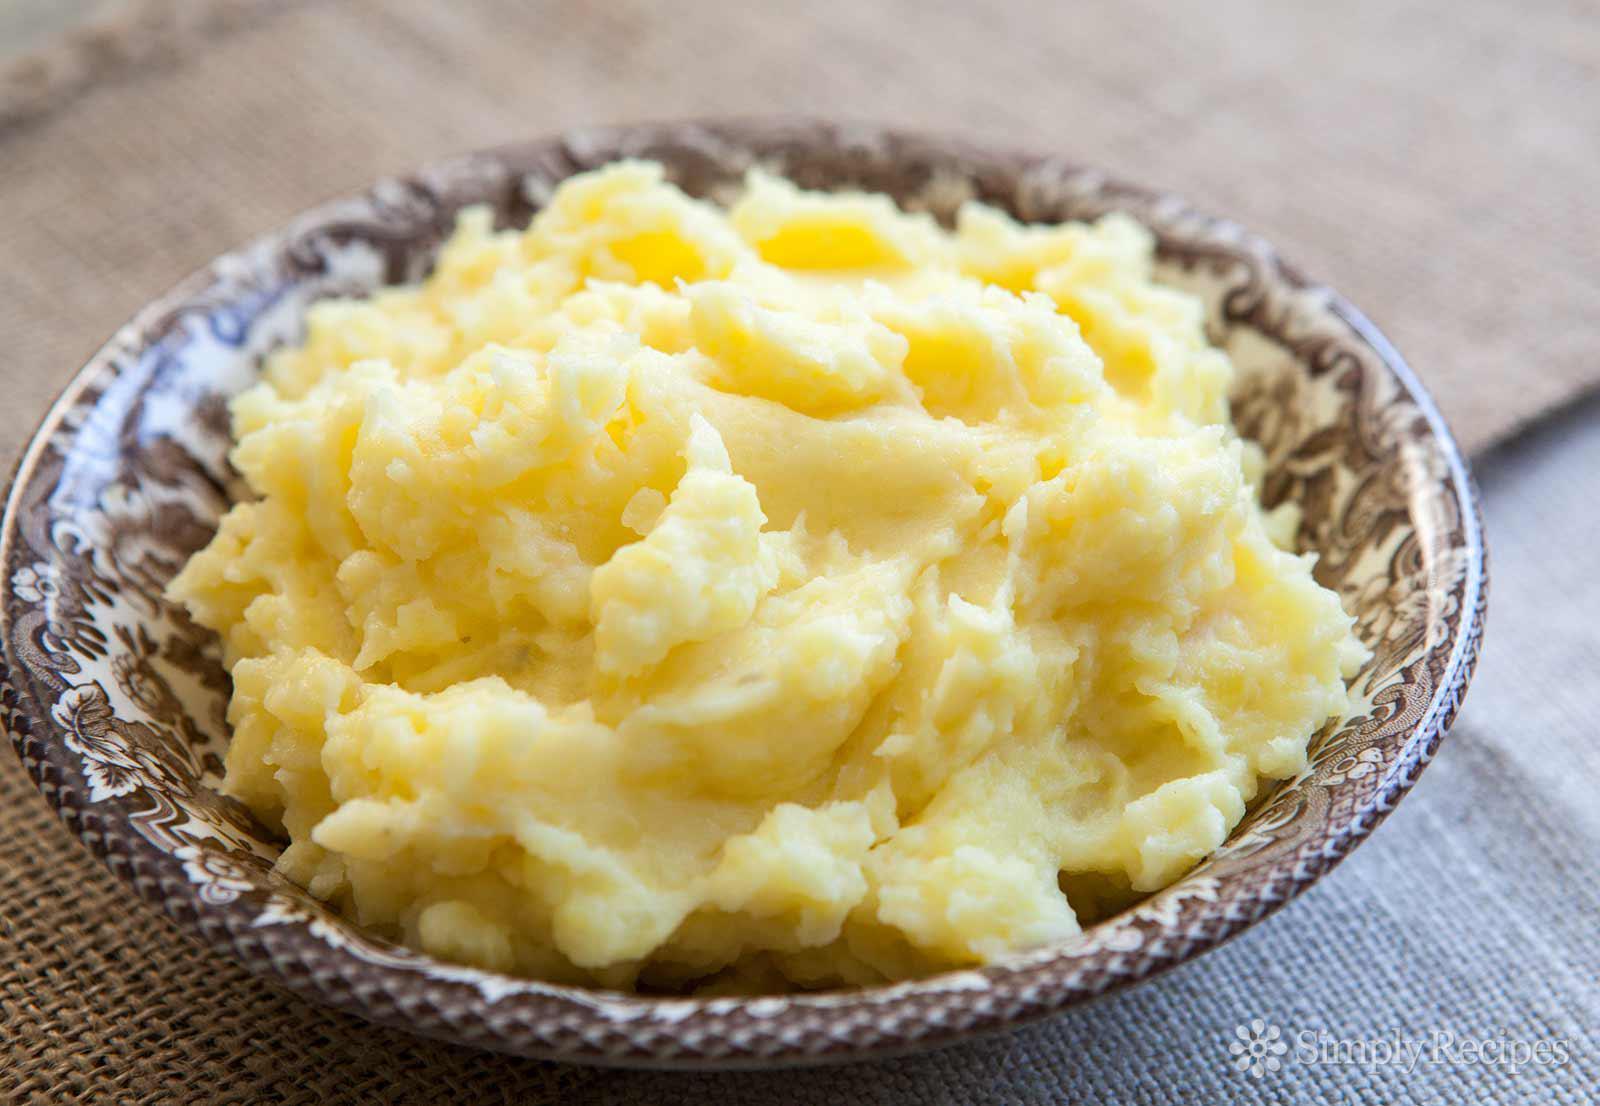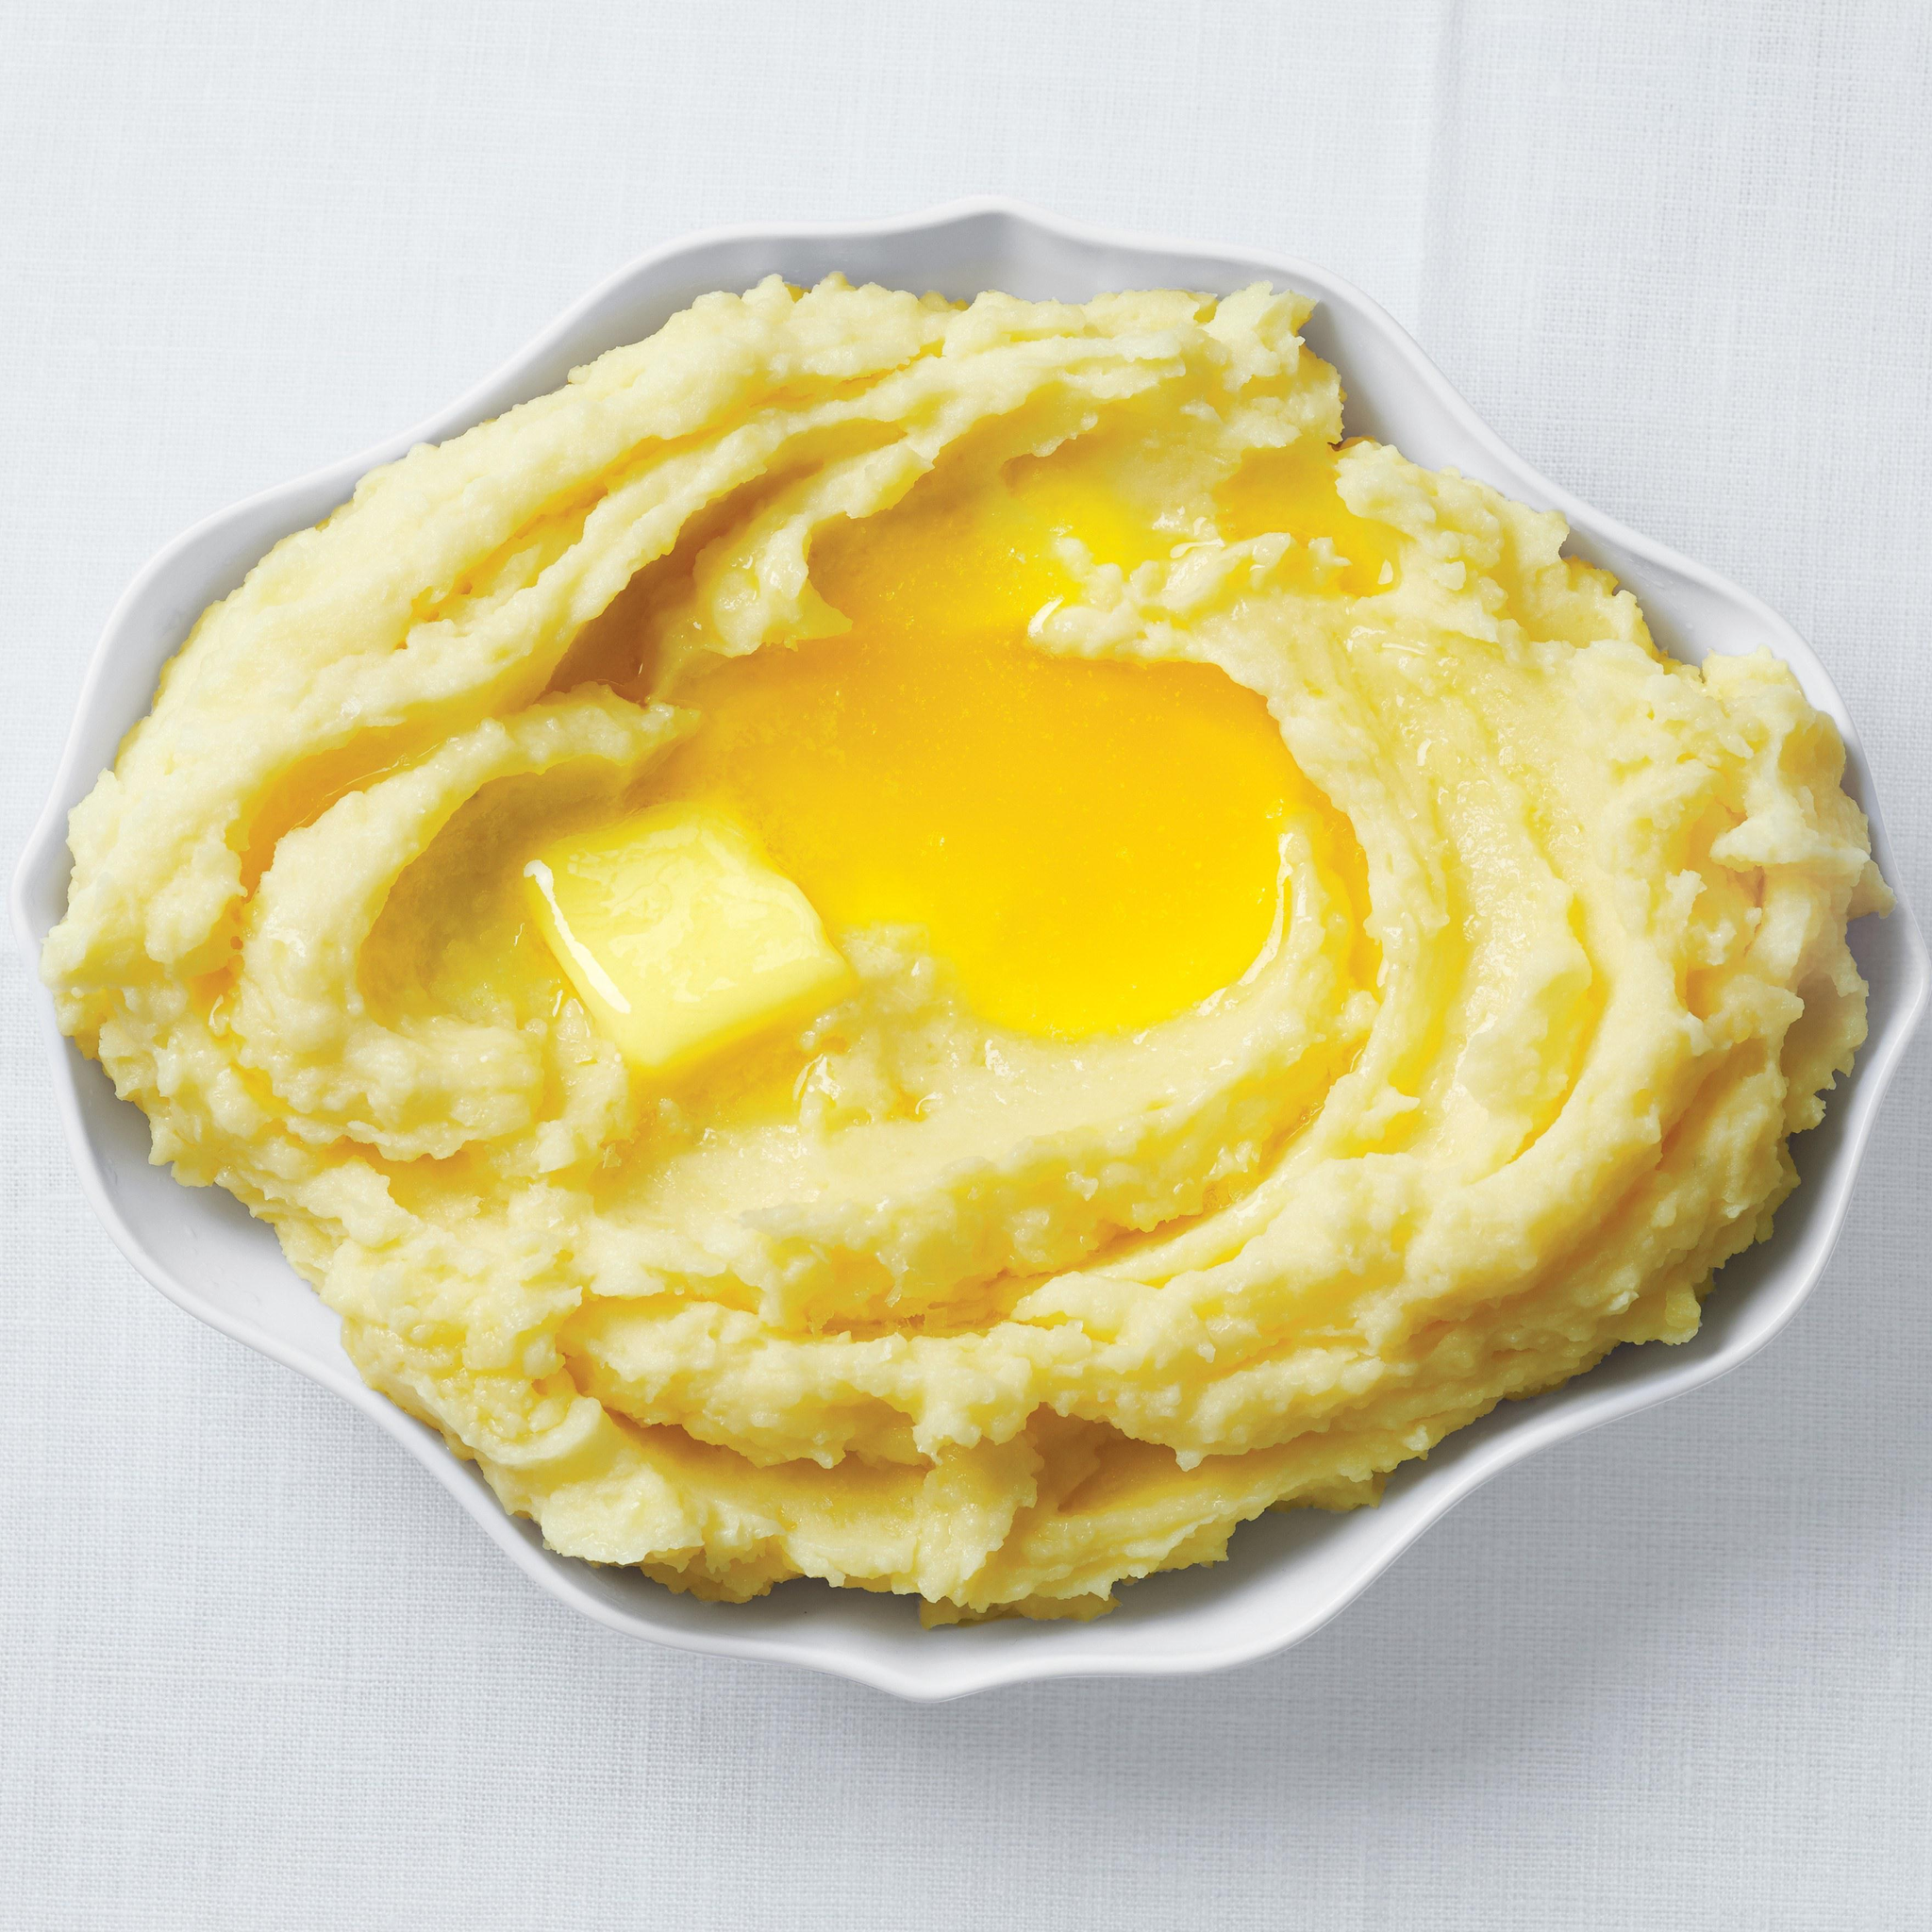The first image is the image on the left, the second image is the image on the right. Evaluate the accuracy of this statement regarding the images: "One imagine in the pair has a slab of butter visible in the mashed potato.". Is it true? Answer yes or no. Yes. 